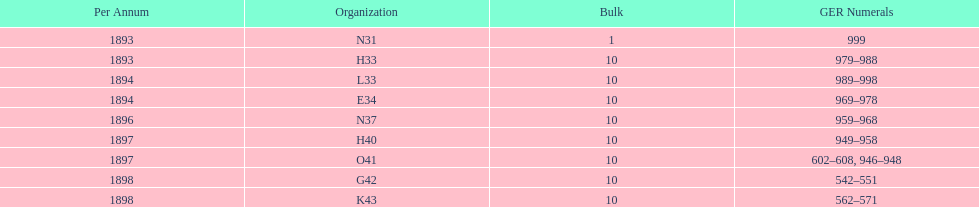Which had more ger numbers, 1898 or 1893? 1898. 